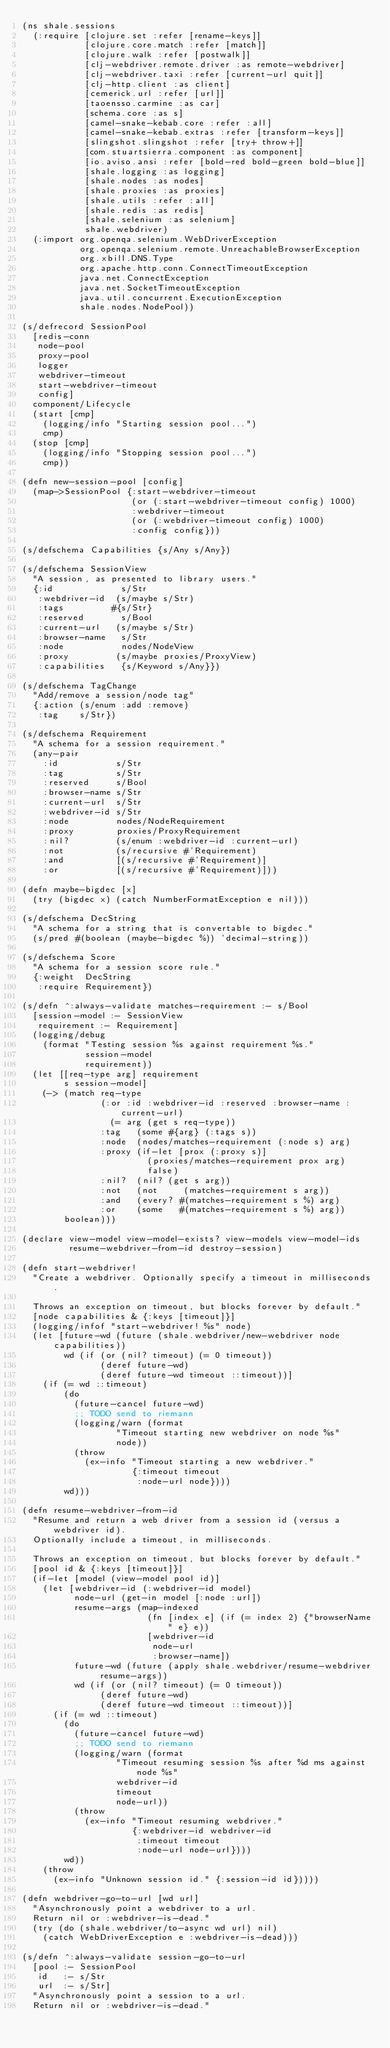<code> <loc_0><loc_0><loc_500><loc_500><_Clojure_>(ns shale.sessions
  (:require [clojure.set :refer [rename-keys]]
            [clojure.core.match :refer [match]]
            [clojure.walk :refer [postwalk]]
            [clj-webdriver.remote.driver :as remote-webdriver]
            [clj-webdriver.taxi :refer [current-url quit]]
            [clj-http.client :as client]
            [cemerick.url :refer [url]]
            [taoensso.carmine :as car]
            [schema.core :as s]
            [camel-snake-kebab.core :refer :all]
            [camel-snake-kebab.extras :refer [transform-keys]]
            [slingshot.slingshot :refer [try+ throw+]]
            [com.stuartsierra.component :as component]
            [io.aviso.ansi :refer [bold-red bold-green bold-blue]]
            [shale.logging :as logging]
            [shale.nodes :as nodes]
            [shale.proxies :as proxies]
            [shale.utils :refer :all]
            [shale.redis :as redis]
            [shale.selenium :as selenium]
            shale.webdriver)
  (:import org.openqa.selenium.WebDriverException
           org.openqa.selenium.remote.UnreachableBrowserException
           org.xbill.DNS.Type
           org.apache.http.conn.ConnectTimeoutException
           java.net.ConnectException
           java.net.SocketTimeoutException
           java.util.concurrent.ExecutionException
           shale.nodes.NodePool))

(s/defrecord SessionPool
  [redis-conn
   node-pool
   proxy-pool
   logger
   webdriver-timeout
   start-webdriver-timeout
   config]
  component/Lifecycle
  (start [cmp]
    (logging/info "Starting session pool...")
    cmp)
  (stop [cmp]
    (logging/info "Stopping session pool...")
    cmp))

(defn new-session-pool [config]
  (map->SessionPool {:start-webdriver-timeout
                     (or (:start-webdriver-timeout config) 1000)
                     :webdriver-timeout
                     (or (:webdriver-timeout config) 1000)
                     :config config}))

(s/defschema Capabilities {s/Any s/Any})

(s/defschema SessionView
  "A session, as presented to library users."
  {:id             s/Str
   :webdriver-id  (s/maybe s/Str)
   :tags         #{s/Str}
   :reserved       s/Bool
   :current-url   (s/maybe s/Str)
   :browser-name   s/Str
   :node           nodes/NodeView
   :proxy         (s/maybe proxies/ProxyView)
   :capabilities   {s/Keyword s/Any}})

(s/defschema TagChange
  "Add/remove a session/node tag"
  {:action (s/enum :add :remove)
   :tag    s/Str})

(s/defschema Requirement
  "A schema for a session requirement."
  (any-pair
    :id           s/Str
    :tag          s/Str
    :reserved     s/Bool
    :browser-name s/Str
    :current-url  s/Str
    :webdriver-id s/Str
    :node         nodes/NodeRequirement
    :proxy        proxies/ProxyRequirement
    :nil?         (s/enum :webdriver-id :current-url)
    :not          (s/recursive #'Requirement)
    :and          [(s/recursive #'Requirement)]
    :or           [(s/recursive #'Requirement)]))

(defn maybe-bigdec [x]
  (try (bigdec x) (catch NumberFormatException e nil)))

(s/defschema DecString
  "A schema for a string that is convertable to bigdec."
  (s/pred #(boolean (maybe-bigdec %)) 'decimal-string))

(s/defschema Score
  "A schema for a session score rule."
  {:weight  DecString
   :require Requirement})

(s/defn ^:always-validate matches-requirement :- s/Bool
  [session-model :- SessionView
   requirement :- Requirement]
  (logging/debug
    (format "Testing session %s against requirement %s."
            session-model
            requirement))
  (let [[req-type arg] requirement
        s session-model]
    (-> (match req-type
               (:or :id :webdriver-id :reserved :browser-name :current-url)
                 (= arg (get s req-type))
               :tag   (some #{arg} (:tags s))
               :node  (nodes/matches-requirement (:node s) arg)
               :proxy (if-let [prox (:proxy s)]
                        (proxies/matches-requirement prox arg)
                        false)
               :nil?  (nil? (get s arg))
               :not   (not     (matches-requirement s arg))
               :and   (every? #(matches-requirement s %) arg)
               :or    (some   #(matches-requirement s %) arg))
        boolean)))

(declare view-model view-model-exists? view-models view-model-ids
         resume-webdriver-from-id destroy-session)

(defn start-webdriver!
  "Create a webdriver. Optionally specify a timeout in milliseconds.

  Throws an exception on timeout, but blocks forever by default."
  [node capabilities & {:keys [timeout]}]
  (logging/infof "start-webdriver! %s" node)
  (let [future-wd (future (shale.webdriver/new-webdriver node capabilities))
        wd (if (or (nil? timeout) (= 0 timeout))
               (deref future-wd)
               (deref future-wd timeout ::timeout))]
    (if (= wd ::timeout)
        (do
          (future-cancel future-wd)
          ;; TODO send to riemann
          (logging/warn (format
                  "Timeout starting new webdriver on node %s"
                  node))
          (throw
            (ex-info "Timeout starting a new webdriver."
                     {:timeout timeout
                      :node-url node})))
        wd)))

(defn resume-webdriver-from-id
  "Resume and return a web driver from a session id (versus a webdriver id).
  Optionally include a timeout, in milliseconds.

  Throws an exception on timeout, but blocks forever by default."
  [pool id & {:keys [timeout]}]
  (if-let [model (view-model pool id)]
    (let [webdriver-id (:webdriver-id model)
          node-url (get-in model [:node :url])
          resume-args (map-indexed
                        (fn [index e] (if (= index 2) {"browserName" e} e))
                        [webdriver-id
                         node-url
                         :browser-name])
          future-wd (future (apply shale.webdriver/resume-webdriver resume-args))
          wd (if (or (nil? timeout) (= 0 timeout))
               (deref future-wd)
               (deref future-wd timeout ::timeout))]
      (if (= wd ::timeout)
        (do
          (future-cancel future-wd)
          ;; TODO send to riemann
          (logging/warn (format
                  "Timeout resuming session %s after %d ms against node %s"
                  webdriver-id
                  timeout
                  node-url))
          (throw
            (ex-info "Timeout resuming webdriver."
                     {:webdriver-id webdriver-id
                      :timeout timeout
                      :node-url node-url})))
        wd))
    (throw
      (ex-info "Unknown session id." {:session-id id}))))

(defn webdriver-go-to-url [wd url]
  "Asynchronously point a webdriver to a url.
  Return nil or :webdriver-is-dead."
  (try (do (shale.webdriver/to-async wd url) nil)
    (catch WebDriverException e :webdriver-is-dead)))

(s/defn ^:always-validate session-go-to-url
  [pool :- SessionPool
   id   :- s/Str
   url  :- s/Str]
  "Asynchronously point a session to a url.
  Return nil or :webdriver-is-dead."</code> 